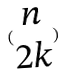Convert formula to latex. <formula><loc_0><loc_0><loc_500><loc_500>( \begin{matrix} n \\ 2 k \end{matrix} )</formula> 